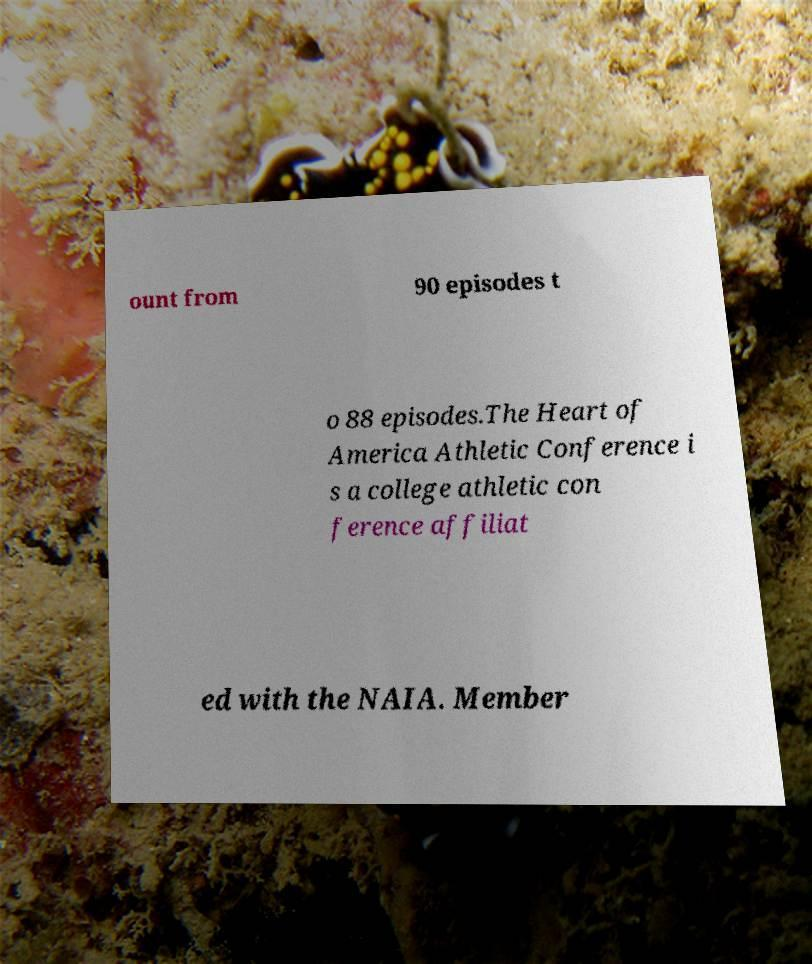Could you assist in decoding the text presented in this image and type it out clearly? ount from 90 episodes t o 88 episodes.The Heart of America Athletic Conference i s a college athletic con ference affiliat ed with the NAIA. Member 